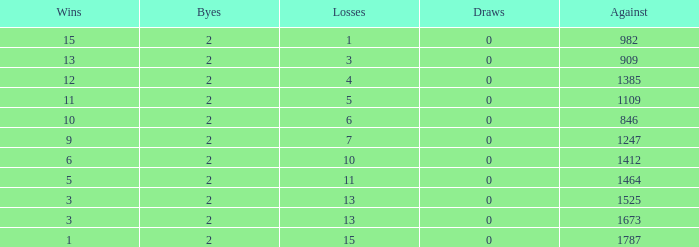What is the average number of Byes when there were less than 0 losses and were against 1247? None. 